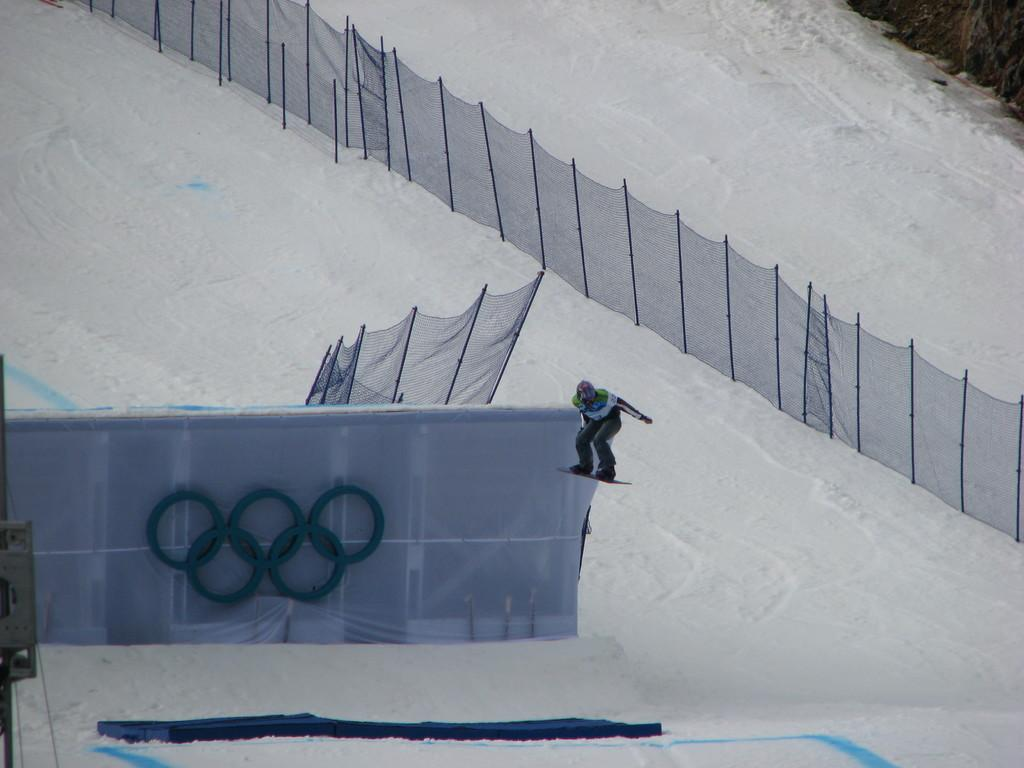What is covering the ground in the image? There is snow on the ground in the image. What can be seen near the person in the image? There are nets visible in the image. What is the person doing in the image? The person is on a snowboard. What type of stove can be seen in the image? There is no stove present in the image. What is the tin used for in the image? There is no tin present in the image. 